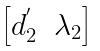Convert formula to latex. <formula><loc_0><loc_0><loc_500><loc_500>\begin{bmatrix} d _ { 2 } ^ { ^ { \prime } } & \lambda _ { 2 } \end{bmatrix}</formula> 